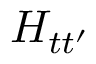Convert formula to latex. <formula><loc_0><loc_0><loc_500><loc_500>H _ { t t ^ { \prime } }</formula> 